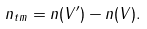Convert formula to latex. <formula><loc_0><loc_0><loc_500><loc_500>n _ { t m } = n ( V ^ { \prime } ) - n ( V ) .</formula> 